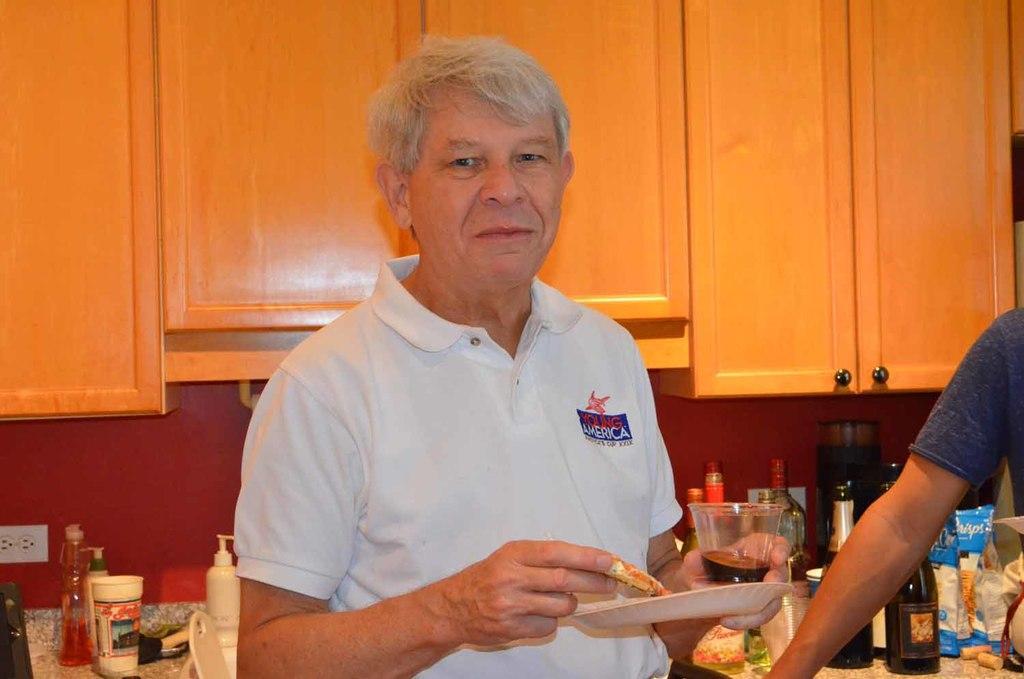Please provide a concise description of this image. In this image we can see two persons. One person wearing a white shirt is holding food in one hand and in other hand, we can see a glass and a plate. In the background, we can see the group of bottles and bags placed on the countertop and some cupboards. 